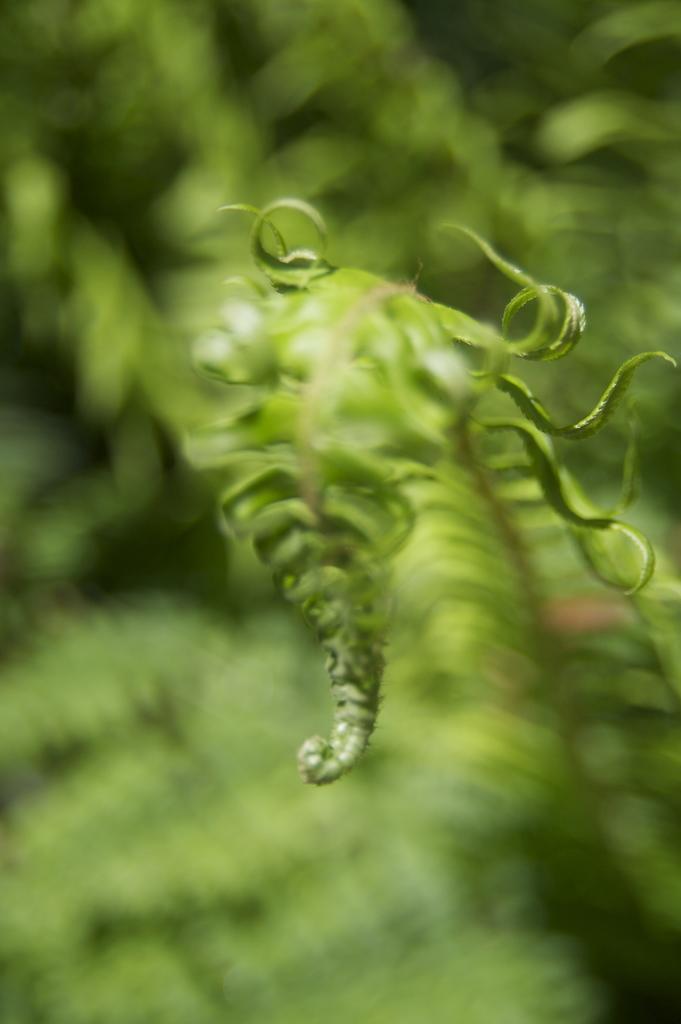Describe this image in one or two sentences. In this picture, it seems to be there is a leaf in the center of the image and there is greenery in the background area of the image. 